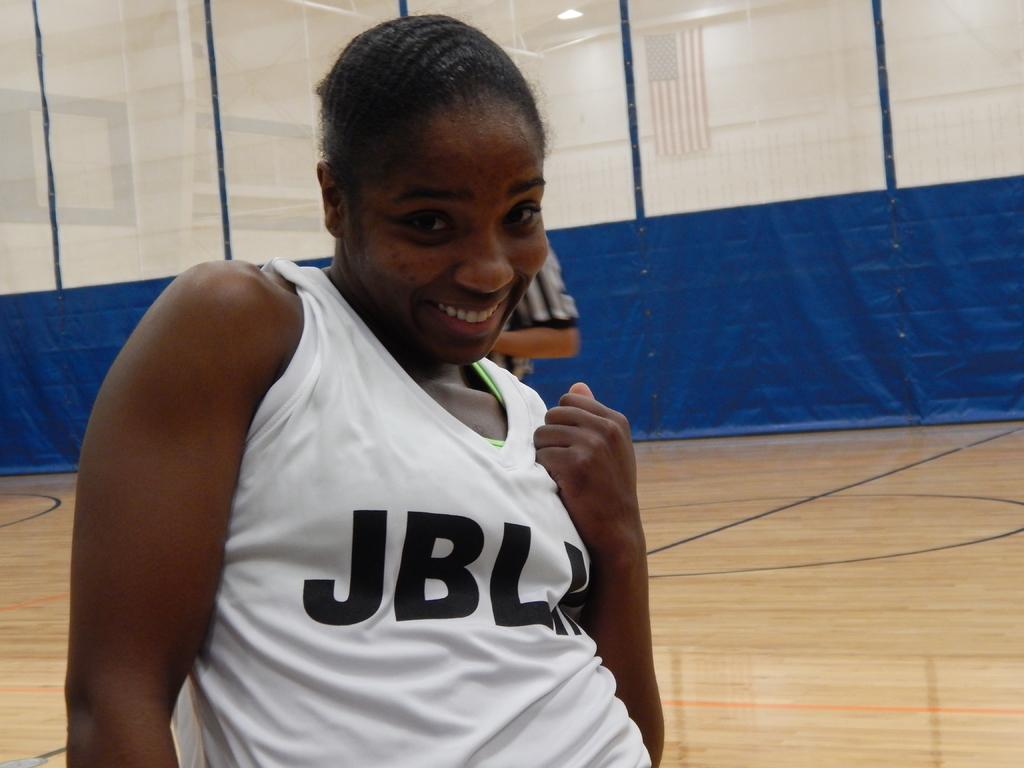What team does the player play for?
Give a very brief answer. Jbl. What is the first letter printed on the girl's shirt?
Make the answer very short. J. 